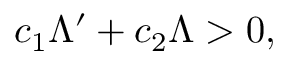Convert formula to latex. <formula><loc_0><loc_0><loc_500><loc_500>c _ { 1 } \Lambda ^ { \prime } + c _ { 2 } \Lambda > 0 ,</formula> 